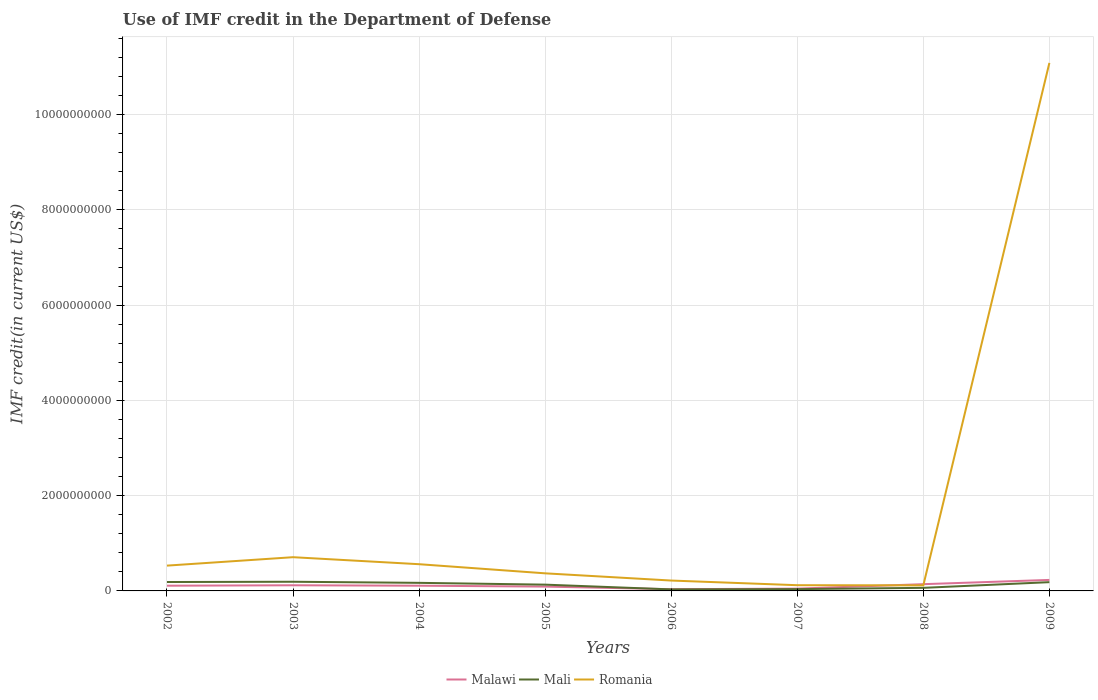Is the number of lines equal to the number of legend labels?
Keep it short and to the point. Yes. Across all years, what is the maximum IMF credit in the Department of Defense in Malawi?
Keep it short and to the point. 3.60e+07. In which year was the IMF credit in the Department of Defense in Malawi maximum?
Ensure brevity in your answer.  2006. What is the total IMF credit in the Department of Defense in Romania in the graph?
Provide a succinct answer. 4.44e+08. What is the difference between the highest and the second highest IMF credit in the Department of Defense in Malawi?
Your answer should be compact. 1.95e+08. What is the difference between two consecutive major ticks on the Y-axis?
Ensure brevity in your answer.  2.00e+09. Are the values on the major ticks of Y-axis written in scientific E-notation?
Your response must be concise. No. Does the graph contain any zero values?
Your response must be concise. No. Does the graph contain grids?
Ensure brevity in your answer.  Yes. What is the title of the graph?
Offer a terse response. Use of IMF credit in the Department of Defense. What is the label or title of the Y-axis?
Ensure brevity in your answer.  IMF credit(in current US$). What is the IMF credit(in current US$) of Malawi in 2002?
Give a very brief answer. 1.09e+08. What is the IMF credit(in current US$) of Mali in 2002?
Make the answer very short. 1.87e+08. What is the IMF credit(in current US$) of Romania in 2002?
Offer a terse response. 5.31e+08. What is the IMF credit(in current US$) in Malawi in 2003?
Your response must be concise. 1.18e+08. What is the IMF credit(in current US$) in Mali in 2003?
Give a very brief answer. 1.92e+08. What is the IMF credit(in current US$) of Romania in 2003?
Your answer should be compact. 7.08e+08. What is the IMF credit(in current US$) in Malawi in 2004?
Your response must be concise. 1.10e+08. What is the IMF credit(in current US$) in Mali in 2004?
Offer a very short reply. 1.70e+08. What is the IMF credit(in current US$) of Romania in 2004?
Offer a terse response. 5.61e+08. What is the IMF credit(in current US$) of Malawi in 2005?
Ensure brevity in your answer.  9.09e+07. What is the IMF credit(in current US$) of Mali in 2005?
Keep it short and to the point. 1.32e+08. What is the IMF credit(in current US$) of Romania in 2005?
Give a very brief answer. 3.69e+08. What is the IMF credit(in current US$) in Malawi in 2006?
Offer a very short reply. 3.60e+07. What is the IMF credit(in current US$) of Mali in 2006?
Your answer should be very brief. 3.20e+07. What is the IMF credit(in current US$) in Romania in 2006?
Offer a terse response. 2.18e+08. What is the IMF credit(in current US$) in Malawi in 2007?
Provide a succinct answer. 4.83e+07. What is the IMF credit(in current US$) in Mali in 2007?
Offer a very short reply. 3.78e+07. What is the IMF credit(in current US$) of Romania in 2007?
Your answer should be very brief. 1.20e+08. What is the IMF credit(in current US$) in Malawi in 2008?
Give a very brief answer. 1.42e+08. What is the IMF credit(in current US$) in Mali in 2008?
Give a very brief answer. 6.45e+07. What is the IMF credit(in current US$) in Romania in 2008?
Ensure brevity in your answer.  1.17e+08. What is the IMF credit(in current US$) in Malawi in 2009?
Provide a short and direct response. 2.31e+08. What is the IMF credit(in current US$) in Mali in 2009?
Make the answer very short. 1.84e+08. What is the IMF credit(in current US$) of Romania in 2009?
Your answer should be compact. 1.11e+1. Across all years, what is the maximum IMF credit(in current US$) of Malawi?
Provide a succinct answer. 2.31e+08. Across all years, what is the maximum IMF credit(in current US$) of Mali?
Keep it short and to the point. 1.92e+08. Across all years, what is the maximum IMF credit(in current US$) of Romania?
Provide a short and direct response. 1.11e+1. Across all years, what is the minimum IMF credit(in current US$) of Malawi?
Offer a terse response. 3.60e+07. Across all years, what is the minimum IMF credit(in current US$) in Mali?
Give a very brief answer. 3.20e+07. Across all years, what is the minimum IMF credit(in current US$) in Romania?
Keep it short and to the point. 1.17e+08. What is the total IMF credit(in current US$) of Malawi in the graph?
Provide a succinct answer. 8.85e+08. What is the total IMF credit(in current US$) of Mali in the graph?
Offer a very short reply. 9.99e+08. What is the total IMF credit(in current US$) of Romania in the graph?
Your answer should be compact. 1.37e+1. What is the difference between the IMF credit(in current US$) of Malawi in 2002 and that in 2003?
Make the answer very short. -9.02e+06. What is the difference between the IMF credit(in current US$) in Mali in 2002 and that in 2003?
Ensure brevity in your answer.  -5.27e+06. What is the difference between the IMF credit(in current US$) of Romania in 2002 and that in 2003?
Provide a short and direct response. -1.77e+08. What is the difference between the IMF credit(in current US$) in Malawi in 2002 and that in 2004?
Ensure brevity in your answer.  -4.00e+04. What is the difference between the IMF credit(in current US$) of Mali in 2002 and that in 2004?
Provide a short and direct response. 1.76e+07. What is the difference between the IMF credit(in current US$) in Romania in 2002 and that in 2004?
Give a very brief answer. -2.97e+07. What is the difference between the IMF credit(in current US$) in Malawi in 2002 and that in 2005?
Provide a short and direct response. 1.86e+07. What is the difference between the IMF credit(in current US$) in Mali in 2002 and that in 2005?
Your answer should be compact. 5.52e+07. What is the difference between the IMF credit(in current US$) of Romania in 2002 and that in 2005?
Provide a succinct answer. 1.62e+08. What is the difference between the IMF credit(in current US$) of Malawi in 2002 and that in 2006?
Offer a terse response. 7.35e+07. What is the difference between the IMF credit(in current US$) of Mali in 2002 and that in 2006?
Provide a succinct answer. 1.55e+08. What is the difference between the IMF credit(in current US$) of Romania in 2002 and that in 2006?
Make the answer very short. 3.14e+08. What is the difference between the IMF credit(in current US$) of Malawi in 2002 and that in 2007?
Offer a very short reply. 6.11e+07. What is the difference between the IMF credit(in current US$) in Mali in 2002 and that in 2007?
Offer a very short reply. 1.49e+08. What is the difference between the IMF credit(in current US$) in Romania in 2002 and that in 2007?
Ensure brevity in your answer.  4.11e+08. What is the difference between the IMF credit(in current US$) in Malawi in 2002 and that in 2008?
Offer a very short reply. -3.21e+07. What is the difference between the IMF credit(in current US$) of Mali in 2002 and that in 2008?
Give a very brief answer. 1.23e+08. What is the difference between the IMF credit(in current US$) of Romania in 2002 and that in 2008?
Offer a terse response. 4.14e+08. What is the difference between the IMF credit(in current US$) in Malawi in 2002 and that in 2009?
Your answer should be compact. -1.21e+08. What is the difference between the IMF credit(in current US$) in Mali in 2002 and that in 2009?
Keep it short and to the point. 3.18e+06. What is the difference between the IMF credit(in current US$) in Romania in 2002 and that in 2009?
Offer a terse response. -1.06e+1. What is the difference between the IMF credit(in current US$) of Malawi in 2003 and that in 2004?
Offer a terse response. 8.98e+06. What is the difference between the IMF credit(in current US$) of Mali in 2003 and that in 2004?
Keep it short and to the point. 2.29e+07. What is the difference between the IMF credit(in current US$) in Romania in 2003 and that in 2004?
Offer a very short reply. 1.47e+08. What is the difference between the IMF credit(in current US$) in Malawi in 2003 and that in 2005?
Make the answer very short. 2.76e+07. What is the difference between the IMF credit(in current US$) in Mali in 2003 and that in 2005?
Provide a short and direct response. 6.05e+07. What is the difference between the IMF credit(in current US$) of Romania in 2003 and that in 2005?
Give a very brief answer. 3.39e+08. What is the difference between the IMF credit(in current US$) in Malawi in 2003 and that in 2006?
Your answer should be very brief. 8.25e+07. What is the difference between the IMF credit(in current US$) in Mali in 2003 and that in 2006?
Offer a very short reply. 1.60e+08. What is the difference between the IMF credit(in current US$) of Romania in 2003 and that in 2006?
Offer a terse response. 4.90e+08. What is the difference between the IMF credit(in current US$) in Malawi in 2003 and that in 2007?
Your answer should be compact. 7.02e+07. What is the difference between the IMF credit(in current US$) of Mali in 2003 and that in 2007?
Your answer should be very brief. 1.55e+08. What is the difference between the IMF credit(in current US$) of Romania in 2003 and that in 2007?
Give a very brief answer. 5.88e+08. What is the difference between the IMF credit(in current US$) of Malawi in 2003 and that in 2008?
Your response must be concise. -2.31e+07. What is the difference between the IMF credit(in current US$) in Mali in 2003 and that in 2008?
Your answer should be very brief. 1.28e+08. What is the difference between the IMF credit(in current US$) of Romania in 2003 and that in 2008?
Your answer should be very brief. 5.91e+08. What is the difference between the IMF credit(in current US$) in Malawi in 2003 and that in 2009?
Provide a succinct answer. -1.12e+08. What is the difference between the IMF credit(in current US$) in Mali in 2003 and that in 2009?
Your answer should be compact. 8.46e+06. What is the difference between the IMF credit(in current US$) of Romania in 2003 and that in 2009?
Make the answer very short. -1.04e+1. What is the difference between the IMF credit(in current US$) of Malawi in 2004 and that in 2005?
Provide a succinct answer. 1.86e+07. What is the difference between the IMF credit(in current US$) in Mali in 2004 and that in 2005?
Your answer should be very brief. 3.76e+07. What is the difference between the IMF credit(in current US$) of Romania in 2004 and that in 2005?
Your answer should be very brief. 1.92e+08. What is the difference between the IMF credit(in current US$) of Malawi in 2004 and that in 2006?
Provide a short and direct response. 7.35e+07. What is the difference between the IMF credit(in current US$) in Mali in 2004 and that in 2006?
Provide a short and direct response. 1.38e+08. What is the difference between the IMF credit(in current US$) in Romania in 2004 and that in 2006?
Make the answer very short. 3.43e+08. What is the difference between the IMF credit(in current US$) in Malawi in 2004 and that in 2007?
Your response must be concise. 6.12e+07. What is the difference between the IMF credit(in current US$) in Mali in 2004 and that in 2007?
Make the answer very short. 1.32e+08. What is the difference between the IMF credit(in current US$) of Romania in 2004 and that in 2007?
Make the answer very short. 4.41e+08. What is the difference between the IMF credit(in current US$) in Malawi in 2004 and that in 2008?
Provide a succinct answer. -3.21e+07. What is the difference between the IMF credit(in current US$) in Mali in 2004 and that in 2008?
Keep it short and to the point. 1.05e+08. What is the difference between the IMF credit(in current US$) in Romania in 2004 and that in 2008?
Provide a succinct answer. 4.44e+08. What is the difference between the IMF credit(in current US$) in Malawi in 2004 and that in 2009?
Provide a succinct answer. -1.21e+08. What is the difference between the IMF credit(in current US$) in Mali in 2004 and that in 2009?
Provide a short and direct response. -1.45e+07. What is the difference between the IMF credit(in current US$) of Romania in 2004 and that in 2009?
Make the answer very short. -1.05e+1. What is the difference between the IMF credit(in current US$) of Malawi in 2005 and that in 2006?
Offer a terse response. 5.49e+07. What is the difference between the IMF credit(in current US$) in Mali in 2005 and that in 2006?
Offer a very short reply. 1.00e+08. What is the difference between the IMF credit(in current US$) of Romania in 2005 and that in 2006?
Your answer should be compact. 1.52e+08. What is the difference between the IMF credit(in current US$) in Malawi in 2005 and that in 2007?
Your response must be concise. 4.25e+07. What is the difference between the IMF credit(in current US$) of Mali in 2005 and that in 2007?
Offer a very short reply. 9.41e+07. What is the difference between the IMF credit(in current US$) in Romania in 2005 and that in 2007?
Make the answer very short. 2.49e+08. What is the difference between the IMF credit(in current US$) in Malawi in 2005 and that in 2008?
Ensure brevity in your answer.  -5.07e+07. What is the difference between the IMF credit(in current US$) of Mali in 2005 and that in 2008?
Your response must be concise. 6.74e+07. What is the difference between the IMF credit(in current US$) of Romania in 2005 and that in 2008?
Offer a terse response. 2.52e+08. What is the difference between the IMF credit(in current US$) of Malawi in 2005 and that in 2009?
Offer a terse response. -1.40e+08. What is the difference between the IMF credit(in current US$) of Mali in 2005 and that in 2009?
Provide a succinct answer. -5.20e+07. What is the difference between the IMF credit(in current US$) of Romania in 2005 and that in 2009?
Ensure brevity in your answer.  -1.07e+1. What is the difference between the IMF credit(in current US$) of Malawi in 2006 and that in 2007?
Offer a terse response. -1.24e+07. What is the difference between the IMF credit(in current US$) of Mali in 2006 and that in 2007?
Keep it short and to the point. -5.84e+06. What is the difference between the IMF credit(in current US$) of Romania in 2006 and that in 2007?
Keep it short and to the point. 9.79e+07. What is the difference between the IMF credit(in current US$) in Malawi in 2006 and that in 2008?
Offer a terse response. -1.06e+08. What is the difference between the IMF credit(in current US$) of Mali in 2006 and that in 2008?
Ensure brevity in your answer.  -3.26e+07. What is the difference between the IMF credit(in current US$) of Romania in 2006 and that in 2008?
Your answer should be compact. 1.01e+08. What is the difference between the IMF credit(in current US$) in Malawi in 2006 and that in 2009?
Offer a very short reply. -1.95e+08. What is the difference between the IMF credit(in current US$) in Mali in 2006 and that in 2009?
Keep it short and to the point. -1.52e+08. What is the difference between the IMF credit(in current US$) of Romania in 2006 and that in 2009?
Offer a terse response. -1.09e+1. What is the difference between the IMF credit(in current US$) in Malawi in 2007 and that in 2008?
Make the answer very short. -9.32e+07. What is the difference between the IMF credit(in current US$) in Mali in 2007 and that in 2008?
Give a very brief answer. -2.68e+07. What is the difference between the IMF credit(in current US$) of Romania in 2007 and that in 2008?
Offer a very short reply. 3.04e+06. What is the difference between the IMF credit(in current US$) in Malawi in 2007 and that in 2009?
Keep it short and to the point. -1.83e+08. What is the difference between the IMF credit(in current US$) in Mali in 2007 and that in 2009?
Your answer should be very brief. -1.46e+08. What is the difference between the IMF credit(in current US$) in Romania in 2007 and that in 2009?
Keep it short and to the point. -1.10e+1. What is the difference between the IMF credit(in current US$) in Malawi in 2008 and that in 2009?
Your answer should be very brief. -8.94e+07. What is the difference between the IMF credit(in current US$) of Mali in 2008 and that in 2009?
Offer a very short reply. -1.19e+08. What is the difference between the IMF credit(in current US$) in Romania in 2008 and that in 2009?
Ensure brevity in your answer.  -1.10e+1. What is the difference between the IMF credit(in current US$) in Malawi in 2002 and the IMF credit(in current US$) in Mali in 2003?
Offer a very short reply. -8.29e+07. What is the difference between the IMF credit(in current US$) of Malawi in 2002 and the IMF credit(in current US$) of Romania in 2003?
Offer a very short reply. -5.99e+08. What is the difference between the IMF credit(in current US$) of Mali in 2002 and the IMF credit(in current US$) of Romania in 2003?
Your answer should be very brief. -5.21e+08. What is the difference between the IMF credit(in current US$) in Malawi in 2002 and the IMF credit(in current US$) in Mali in 2004?
Give a very brief answer. -6.00e+07. What is the difference between the IMF credit(in current US$) of Malawi in 2002 and the IMF credit(in current US$) of Romania in 2004?
Your answer should be compact. -4.52e+08. What is the difference between the IMF credit(in current US$) of Mali in 2002 and the IMF credit(in current US$) of Romania in 2004?
Make the answer very short. -3.74e+08. What is the difference between the IMF credit(in current US$) of Malawi in 2002 and the IMF credit(in current US$) of Mali in 2005?
Your response must be concise. -2.25e+07. What is the difference between the IMF credit(in current US$) in Malawi in 2002 and the IMF credit(in current US$) in Romania in 2005?
Ensure brevity in your answer.  -2.60e+08. What is the difference between the IMF credit(in current US$) in Mali in 2002 and the IMF credit(in current US$) in Romania in 2005?
Provide a short and direct response. -1.82e+08. What is the difference between the IMF credit(in current US$) of Malawi in 2002 and the IMF credit(in current US$) of Mali in 2006?
Your answer should be very brief. 7.75e+07. What is the difference between the IMF credit(in current US$) of Malawi in 2002 and the IMF credit(in current US$) of Romania in 2006?
Your answer should be compact. -1.08e+08. What is the difference between the IMF credit(in current US$) of Mali in 2002 and the IMF credit(in current US$) of Romania in 2006?
Offer a terse response. -3.07e+07. What is the difference between the IMF credit(in current US$) in Malawi in 2002 and the IMF credit(in current US$) in Mali in 2007?
Your answer should be very brief. 7.17e+07. What is the difference between the IMF credit(in current US$) in Malawi in 2002 and the IMF credit(in current US$) in Romania in 2007?
Give a very brief answer. -1.05e+07. What is the difference between the IMF credit(in current US$) in Mali in 2002 and the IMF credit(in current US$) in Romania in 2007?
Your response must be concise. 6.71e+07. What is the difference between the IMF credit(in current US$) in Malawi in 2002 and the IMF credit(in current US$) in Mali in 2008?
Provide a short and direct response. 4.49e+07. What is the difference between the IMF credit(in current US$) of Malawi in 2002 and the IMF credit(in current US$) of Romania in 2008?
Offer a very short reply. -7.51e+06. What is the difference between the IMF credit(in current US$) of Mali in 2002 and the IMF credit(in current US$) of Romania in 2008?
Give a very brief answer. 7.02e+07. What is the difference between the IMF credit(in current US$) in Malawi in 2002 and the IMF credit(in current US$) in Mali in 2009?
Provide a succinct answer. -7.45e+07. What is the difference between the IMF credit(in current US$) of Malawi in 2002 and the IMF credit(in current US$) of Romania in 2009?
Offer a terse response. -1.10e+1. What is the difference between the IMF credit(in current US$) of Mali in 2002 and the IMF credit(in current US$) of Romania in 2009?
Your answer should be compact. -1.09e+1. What is the difference between the IMF credit(in current US$) in Malawi in 2003 and the IMF credit(in current US$) in Mali in 2004?
Give a very brief answer. -5.10e+07. What is the difference between the IMF credit(in current US$) of Malawi in 2003 and the IMF credit(in current US$) of Romania in 2004?
Ensure brevity in your answer.  -4.43e+08. What is the difference between the IMF credit(in current US$) in Mali in 2003 and the IMF credit(in current US$) in Romania in 2004?
Your answer should be very brief. -3.69e+08. What is the difference between the IMF credit(in current US$) in Malawi in 2003 and the IMF credit(in current US$) in Mali in 2005?
Give a very brief answer. -1.34e+07. What is the difference between the IMF credit(in current US$) of Malawi in 2003 and the IMF credit(in current US$) of Romania in 2005?
Make the answer very short. -2.51e+08. What is the difference between the IMF credit(in current US$) of Mali in 2003 and the IMF credit(in current US$) of Romania in 2005?
Your response must be concise. -1.77e+08. What is the difference between the IMF credit(in current US$) in Malawi in 2003 and the IMF credit(in current US$) in Mali in 2006?
Provide a succinct answer. 8.65e+07. What is the difference between the IMF credit(in current US$) in Malawi in 2003 and the IMF credit(in current US$) in Romania in 2006?
Your response must be concise. -9.94e+07. What is the difference between the IMF credit(in current US$) in Mali in 2003 and the IMF credit(in current US$) in Romania in 2006?
Your response must be concise. -2.55e+07. What is the difference between the IMF credit(in current US$) of Malawi in 2003 and the IMF credit(in current US$) of Mali in 2007?
Offer a terse response. 8.07e+07. What is the difference between the IMF credit(in current US$) of Malawi in 2003 and the IMF credit(in current US$) of Romania in 2007?
Offer a terse response. -1.52e+06. What is the difference between the IMF credit(in current US$) of Mali in 2003 and the IMF credit(in current US$) of Romania in 2007?
Offer a terse response. 7.24e+07. What is the difference between the IMF credit(in current US$) in Malawi in 2003 and the IMF credit(in current US$) in Mali in 2008?
Ensure brevity in your answer.  5.40e+07. What is the difference between the IMF credit(in current US$) of Malawi in 2003 and the IMF credit(in current US$) of Romania in 2008?
Ensure brevity in your answer.  1.51e+06. What is the difference between the IMF credit(in current US$) in Mali in 2003 and the IMF credit(in current US$) in Romania in 2008?
Your answer should be compact. 7.54e+07. What is the difference between the IMF credit(in current US$) of Malawi in 2003 and the IMF credit(in current US$) of Mali in 2009?
Make the answer very short. -6.55e+07. What is the difference between the IMF credit(in current US$) in Malawi in 2003 and the IMF credit(in current US$) in Romania in 2009?
Provide a succinct answer. -1.10e+1. What is the difference between the IMF credit(in current US$) of Mali in 2003 and the IMF credit(in current US$) of Romania in 2009?
Provide a succinct answer. -1.09e+1. What is the difference between the IMF credit(in current US$) of Malawi in 2004 and the IMF credit(in current US$) of Mali in 2005?
Provide a short and direct response. -2.24e+07. What is the difference between the IMF credit(in current US$) in Malawi in 2004 and the IMF credit(in current US$) in Romania in 2005?
Provide a succinct answer. -2.60e+08. What is the difference between the IMF credit(in current US$) in Mali in 2004 and the IMF credit(in current US$) in Romania in 2005?
Your response must be concise. -2.00e+08. What is the difference between the IMF credit(in current US$) in Malawi in 2004 and the IMF credit(in current US$) in Mali in 2006?
Offer a very short reply. 7.76e+07. What is the difference between the IMF credit(in current US$) in Malawi in 2004 and the IMF credit(in current US$) in Romania in 2006?
Provide a short and direct response. -1.08e+08. What is the difference between the IMF credit(in current US$) of Mali in 2004 and the IMF credit(in current US$) of Romania in 2006?
Offer a terse response. -4.84e+07. What is the difference between the IMF credit(in current US$) of Malawi in 2004 and the IMF credit(in current US$) of Mali in 2007?
Offer a terse response. 7.17e+07. What is the difference between the IMF credit(in current US$) in Malawi in 2004 and the IMF credit(in current US$) in Romania in 2007?
Offer a terse response. -1.05e+07. What is the difference between the IMF credit(in current US$) of Mali in 2004 and the IMF credit(in current US$) of Romania in 2007?
Your answer should be compact. 4.95e+07. What is the difference between the IMF credit(in current US$) in Malawi in 2004 and the IMF credit(in current US$) in Mali in 2008?
Keep it short and to the point. 4.50e+07. What is the difference between the IMF credit(in current US$) in Malawi in 2004 and the IMF credit(in current US$) in Romania in 2008?
Provide a short and direct response. -7.47e+06. What is the difference between the IMF credit(in current US$) in Mali in 2004 and the IMF credit(in current US$) in Romania in 2008?
Your answer should be very brief. 5.25e+07. What is the difference between the IMF credit(in current US$) of Malawi in 2004 and the IMF credit(in current US$) of Mali in 2009?
Make the answer very short. -7.45e+07. What is the difference between the IMF credit(in current US$) in Malawi in 2004 and the IMF credit(in current US$) in Romania in 2009?
Offer a terse response. -1.10e+1. What is the difference between the IMF credit(in current US$) in Mali in 2004 and the IMF credit(in current US$) in Romania in 2009?
Your answer should be very brief. -1.09e+1. What is the difference between the IMF credit(in current US$) of Malawi in 2005 and the IMF credit(in current US$) of Mali in 2006?
Provide a short and direct response. 5.89e+07. What is the difference between the IMF credit(in current US$) of Malawi in 2005 and the IMF credit(in current US$) of Romania in 2006?
Your answer should be compact. -1.27e+08. What is the difference between the IMF credit(in current US$) of Mali in 2005 and the IMF credit(in current US$) of Romania in 2006?
Offer a terse response. -8.60e+07. What is the difference between the IMF credit(in current US$) of Malawi in 2005 and the IMF credit(in current US$) of Mali in 2007?
Provide a short and direct response. 5.31e+07. What is the difference between the IMF credit(in current US$) in Malawi in 2005 and the IMF credit(in current US$) in Romania in 2007?
Ensure brevity in your answer.  -2.92e+07. What is the difference between the IMF credit(in current US$) of Mali in 2005 and the IMF credit(in current US$) of Romania in 2007?
Provide a succinct answer. 1.19e+07. What is the difference between the IMF credit(in current US$) of Malawi in 2005 and the IMF credit(in current US$) of Mali in 2008?
Ensure brevity in your answer.  2.63e+07. What is the difference between the IMF credit(in current US$) in Malawi in 2005 and the IMF credit(in current US$) in Romania in 2008?
Offer a terse response. -2.61e+07. What is the difference between the IMF credit(in current US$) of Mali in 2005 and the IMF credit(in current US$) of Romania in 2008?
Ensure brevity in your answer.  1.49e+07. What is the difference between the IMF credit(in current US$) in Malawi in 2005 and the IMF credit(in current US$) in Mali in 2009?
Make the answer very short. -9.31e+07. What is the difference between the IMF credit(in current US$) in Malawi in 2005 and the IMF credit(in current US$) in Romania in 2009?
Provide a short and direct response. -1.10e+1. What is the difference between the IMF credit(in current US$) in Mali in 2005 and the IMF credit(in current US$) in Romania in 2009?
Ensure brevity in your answer.  -1.10e+1. What is the difference between the IMF credit(in current US$) of Malawi in 2006 and the IMF credit(in current US$) of Mali in 2007?
Provide a succinct answer. -1.82e+06. What is the difference between the IMF credit(in current US$) of Malawi in 2006 and the IMF credit(in current US$) of Romania in 2007?
Keep it short and to the point. -8.40e+07. What is the difference between the IMF credit(in current US$) of Mali in 2006 and the IMF credit(in current US$) of Romania in 2007?
Make the answer very short. -8.81e+07. What is the difference between the IMF credit(in current US$) of Malawi in 2006 and the IMF credit(in current US$) of Mali in 2008?
Provide a short and direct response. -2.86e+07. What is the difference between the IMF credit(in current US$) of Malawi in 2006 and the IMF credit(in current US$) of Romania in 2008?
Provide a short and direct response. -8.10e+07. What is the difference between the IMF credit(in current US$) of Mali in 2006 and the IMF credit(in current US$) of Romania in 2008?
Ensure brevity in your answer.  -8.50e+07. What is the difference between the IMF credit(in current US$) in Malawi in 2006 and the IMF credit(in current US$) in Mali in 2009?
Provide a short and direct response. -1.48e+08. What is the difference between the IMF credit(in current US$) of Malawi in 2006 and the IMF credit(in current US$) of Romania in 2009?
Keep it short and to the point. -1.11e+1. What is the difference between the IMF credit(in current US$) of Mali in 2006 and the IMF credit(in current US$) of Romania in 2009?
Provide a succinct answer. -1.11e+1. What is the difference between the IMF credit(in current US$) of Malawi in 2007 and the IMF credit(in current US$) of Mali in 2008?
Provide a succinct answer. -1.62e+07. What is the difference between the IMF credit(in current US$) in Malawi in 2007 and the IMF credit(in current US$) in Romania in 2008?
Your answer should be compact. -6.86e+07. What is the difference between the IMF credit(in current US$) of Mali in 2007 and the IMF credit(in current US$) of Romania in 2008?
Offer a very short reply. -7.92e+07. What is the difference between the IMF credit(in current US$) in Malawi in 2007 and the IMF credit(in current US$) in Mali in 2009?
Keep it short and to the point. -1.36e+08. What is the difference between the IMF credit(in current US$) of Malawi in 2007 and the IMF credit(in current US$) of Romania in 2009?
Offer a very short reply. -1.10e+1. What is the difference between the IMF credit(in current US$) in Mali in 2007 and the IMF credit(in current US$) in Romania in 2009?
Keep it short and to the point. -1.11e+1. What is the difference between the IMF credit(in current US$) in Malawi in 2008 and the IMF credit(in current US$) in Mali in 2009?
Offer a terse response. -4.24e+07. What is the difference between the IMF credit(in current US$) of Malawi in 2008 and the IMF credit(in current US$) of Romania in 2009?
Provide a short and direct response. -1.09e+1. What is the difference between the IMF credit(in current US$) of Mali in 2008 and the IMF credit(in current US$) of Romania in 2009?
Your answer should be very brief. -1.10e+1. What is the average IMF credit(in current US$) in Malawi per year?
Your answer should be very brief. 1.11e+08. What is the average IMF credit(in current US$) in Mali per year?
Provide a short and direct response. 1.25e+08. What is the average IMF credit(in current US$) of Romania per year?
Make the answer very short. 1.71e+09. In the year 2002, what is the difference between the IMF credit(in current US$) in Malawi and IMF credit(in current US$) in Mali?
Give a very brief answer. -7.77e+07. In the year 2002, what is the difference between the IMF credit(in current US$) of Malawi and IMF credit(in current US$) of Romania?
Ensure brevity in your answer.  -4.22e+08. In the year 2002, what is the difference between the IMF credit(in current US$) of Mali and IMF credit(in current US$) of Romania?
Offer a very short reply. -3.44e+08. In the year 2003, what is the difference between the IMF credit(in current US$) in Malawi and IMF credit(in current US$) in Mali?
Your response must be concise. -7.39e+07. In the year 2003, what is the difference between the IMF credit(in current US$) in Malawi and IMF credit(in current US$) in Romania?
Offer a very short reply. -5.90e+08. In the year 2003, what is the difference between the IMF credit(in current US$) of Mali and IMF credit(in current US$) of Romania?
Keep it short and to the point. -5.16e+08. In the year 2004, what is the difference between the IMF credit(in current US$) of Malawi and IMF credit(in current US$) of Mali?
Make the answer very short. -6.00e+07. In the year 2004, what is the difference between the IMF credit(in current US$) in Malawi and IMF credit(in current US$) in Romania?
Ensure brevity in your answer.  -4.52e+08. In the year 2004, what is the difference between the IMF credit(in current US$) in Mali and IMF credit(in current US$) in Romania?
Your answer should be compact. -3.92e+08. In the year 2005, what is the difference between the IMF credit(in current US$) of Malawi and IMF credit(in current US$) of Mali?
Give a very brief answer. -4.11e+07. In the year 2005, what is the difference between the IMF credit(in current US$) of Malawi and IMF credit(in current US$) of Romania?
Give a very brief answer. -2.79e+08. In the year 2005, what is the difference between the IMF credit(in current US$) of Mali and IMF credit(in current US$) of Romania?
Make the answer very short. -2.38e+08. In the year 2006, what is the difference between the IMF credit(in current US$) of Malawi and IMF credit(in current US$) of Mali?
Provide a short and direct response. 4.02e+06. In the year 2006, what is the difference between the IMF credit(in current US$) of Malawi and IMF credit(in current US$) of Romania?
Offer a very short reply. -1.82e+08. In the year 2006, what is the difference between the IMF credit(in current US$) in Mali and IMF credit(in current US$) in Romania?
Give a very brief answer. -1.86e+08. In the year 2007, what is the difference between the IMF credit(in current US$) in Malawi and IMF credit(in current US$) in Mali?
Offer a terse response. 1.06e+07. In the year 2007, what is the difference between the IMF credit(in current US$) in Malawi and IMF credit(in current US$) in Romania?
Ensure brevity in your answer.  -7.17e+07. In the year 2007, what is the difference between the IMF credit(in current US$) in Mali and IMF credit(in current US$) in Romania?
Your response must be concise. -8.22e+07. In the year 2008, what is the difference between the IMF credit(in current US$) in Malawi and IMF credit(in current US$) in Mali?
Provide a succinct answer. 7.70e+07. In the year 2008, what is the difference between the IMF credit(in current US$) in Malawi and IMF credit(in current US$) in Romania?
Make the answer very short. 2.46e+07. In the year 2008, what is the difference between the IMF credit(in current US$) of Mali and IMF credit(in current US$) of Romania?
Your answer should be compact. -5.24e+07. In the year 2009, what is the difference between the IMF credit(in current US$) of Malawi and IMF credit(in current US$) of Mali?
Provide a short and direct response. 4.70e+07. In the year 2009, what is the difference between the IMF credit(in current US$) in Malawi and IMF credit(in current US$) in Romania?
Ensure brevity in your answer.  -1.09e+1. In the year 2009, what is the difference between the IMF credit(in current US$) in Mali and IMF credit(in current US$) in Romania?
Keep it short and to the point. -1.09e+1. What is the ratio of the IMF credit(in current US$) in Malawi in 2002 to that in 2003?
Your answer should be compact. 0.92. What is the ratio of the IMF credit(in current US$) in Mali in 2002 to that in 2003?
Provide a short and direct response. 0.97. What is the ratio of the IMF credit(in current US$) in Romania in 2002 to that in 2003?
Provide a short and direct response. 0.75. What is the ratio of the IMF credit(in current US$) in Mali in 2002 to that in 2004?
Make the answer very short. 1.1. What is the ratio of the IMF credit(in current US$) in Romania in 2002 to that in 2004?
Keep it short and to the point. 0.95. What is the ratio of the IMF credit(in current US$) of Malawi in 2002 to that in 2005?
Offer a terse response. 1.2. What is the ratio of the IMF credit(in current US$) in Mali in 2002 to that in 2005?
Your response must be concise. 1.42. What is the ratio of the IMF credit(in current US$) in Romania in 2002 to that in 2005?
Keep it short and to the point. 1.44. What is the ratio of the IMF credit(in current US$) of Malawi in 2002 to that in 2006?
Provide a short and direct response. 3.04. What is the ratio of the IMF credit(in current US$) in Mali in 2002 to that in 2006?
Your answer should be very brief. 5.86. What is the ratio of the IMF credit(in current US$) of Romania in 2002 to that in 2006?
Provide a short and direct response. 2.44. What is the ratio of the IMF credit(in current US$) in Malawi in 2002 to that in 2007?
Your response must be concise. 2.26. What is the ratio of the IMF credit(in current US$) of Mali in 2002 to that in 2007?
Your answer should be compact. 4.95. What is the ratio of the IMF credit(in current US$) in Romania in 2002 to that in 2007?
Offer a terse response. 4.43. What is the ratio of the IMF credit(in current US$) of Malawi in 2002 to that in 2008?
Your response must be concise. 0.77. What is the ratio of the IMF credit(in current US$) of Mali in 2002 to that in 2008?
Keep it short and to the point. 2.9. What is the ratio of the IMF credit(in current US$) in Romania in 2002 to that in 2008?
Offer a very short reply. 4.54. What is the ratio of the IMF credit(in current US$) in Malawi in 2002 to that in 2009?
Keep it short and to the point. 0.47. What is the ratio of the IMF credit(in current US$) in Mali in 2002 to that in 2009?
Your response must be concise. 1.02. What is the ratio of the IMF credit(in current US$) in Romania in 2002 to that in 2009?
Make the answer very short. 0.05. What is the ratio of the IMF credit(in current US$) in Malawi in 2003 to that in 2004?
Ensure brevity in your answer.  1.08. What is the ratio of the IMF credit(in current US$) in Mali in 2003 to that in 2004?
Your answer should be compact. 1.14. What is the ratio of the IMF credit(in current US$) of Romania in 2003 to that in 2004?
Your answer should be compact. 1.26. What is the ratio of the IMF credit(in current US$) of Malawi in 2003 to that in 2005?
Your response must be concise. 1.3. What is the ratio of the IMF credit(in current US$) in Mali in 2003 to that in 2005?
Offer a very short reply. 1.46. What is the ratio of the IMF credit(in current US$) of Romania in 2003 to that in 2005?
Provide a short and direct response. 1.92. What is the ratio of the IMF credit(in current US$) of Malawi in 2003 to that in 2006?
Make the answer very short. 3.29. What is the ratio of the IMF credit(in current US$) of Mali in 2003 to that in 2006?
Your response must be concise. 6.02. What is the ratio of the IMF credit(in current US$) in Romania in 2003 to that in 2006?
Your response must be concise. 3.25. What is the ratio of the IMF credit(in current US$) of Malawi in 2003 to that in 2007?
Ensure brevity in your answer.  2.45. What is the ratio of the IMF credit(in current US$) of Mali in 2003 to that in 2007?
Your response must be concise. 5.09. What is the ratio of the IMF credit(in current US$) in Romania in 2003 to that in 2007?
Provide a succinct answer. 5.9. What is the ratio of the IMF credit(in current US$) in Malawi in 2003 to that in 2008?
Provide a short and direct response. 0.84. What is the ratio of the IMF credit(in current US$) of Mali in 2003 to that in 2008?
Provide a succinct answer. 2.98. What is the ratio of the IMF credit(in current US$) of Romania in 2003 to that in 2008?
Ensure brevity in your answer.  6.05. What is the ratio of the IMF credit(in current US$) in Malawi in 2003 to that in 2009?
Your answer should be compact. 0.51. What is the ratio of the IMF credit(in current US$) in Mali in 2003 to that in 2009?
Offer a terse response. 1.05. What is the ratio of the IMF credit(in current US$) of Romania in 2003 to that in 2009?
Offer a very short reply. 0.06. What is the ratio of the IMF credit(in current US$) of Malawi in 2004 to that in 2005?
Provide a succinct answer. 1.21. What is the ratio of the IMF credit(in current US$) in Mali in 2004 to that in 2005?
Keep it short and to the point. 1.28. What is the ratio of the IMF credit(in current US$) of Romania in 2004 to that in 2005?
Keep it short and to the point. 1.52. What is the ratio of the IMF credit(in current US$) in Malawi in 2004 to that in 2006?
Give a very brief answer. 3.04. What is the ratio of the IMF credit(in current US$) in Mali in 2004 to that in 2006?
Give a very brief answer. 5.31. What is the ratio of the IMF credit(in current US$) of Romania in 2004 to that in 2006?
Your answer should be compact. 2.58. What is the ratio of the IMF credit(in current US$) of Malawi in 2004 to that in 2007?
Your answer should be very brief. 2.27. What is the ratio of the IMF credit(in current US$) of Mali in 2004 to that in 2007?
Make the answer very short. 4.49. What is the ratio of the IMF credit(in current US$) in Romania in 2004 to that in 2007?
Give a very brief answer. 4.68. What is the ratio of the IMF credit(in current US$) in Malawi in 2004 to that in 2008?
Provide a succinct answer. 0.77. What is the ratio of the IMF credit(in current US$) of Mali in 2004 to that in 2008?
Give a very brief answer. 2.63. What is the ratio of the IMF credit(in current US$) in Romania in 2004 to that in 2008?
Your answer should be compact. 4.8. What is the ratio of the IMF credit(in current US$) in Malawi in 2004 to that in 2009?
Provide a short and direct response. 0.47. What is the ratio of the IMF credit(in current US$) in Mali in 2004 to that in 2009?
Give a very brief answer. 0.92. What is the ratio of the IMF credit(in current US$) of Romania in 2004 to that in 2009?
Your response must be concise. 0.05. What is the ratio of the IMF credit(in current US$) of Malawi in 2005 to that in 2006?
Keep it short and to the point. 2.53. What is the ratio of the IMF credit(in current US$) of Mali in 2005 to that in 2006?
Your response must be concise. 4.13. What is the ratio of the IMF credit(in current US$) in Romania in 2005 to that in 2006?
Your answer should be very brief. 1.7. What is the ratio of the IMF credit(in current US$) in Malawi in 2005 to that in 2007?
Ensure brevity in your answer.  1.88. What is the ratio of the IMF credit(in current US$) in Mali in 2005 to that in 2007?
Your answer should be very brief. 3.49. What is the ratio of the IMF credit(in current US$) of Romania in 2005 to that in 2007?
Offer a very short reply. 3.08. What is the ratio of the IMF credit(in current US$) in Malawi in 2005 to that in 2008?
Provide a succinct answer. 0.64. What is the ratio of the IMF credit(in current US$) in Mali in 2005 to that in 2008?
Your answer should be very brief. 2.04. What is the ratio of the IMF credit(in current US$) of Romania in 2005 to that in 2008?
Your response must be concise. 3.16. What is the ratio of the IMF credit(in current US$) in Malawi in 2005 to that in 2009?
Ensure brevity in your answer.  0.39. What is the ratio of the IMF credit(in current US$) in Mali in 2005 to that in 2009?
Your answer should be very brief. 0.72. What is the ratio of the IMF credit(in current US$) of Romania in 2005 to that in 2009?
Your response must be concise. 0.03. What is the ratio of the IMF credit(in current US$) in Malawi in 2006 to that in 2007?
Provide a succinct answer. 0.74. What is the ratio of the IMF credit(in current US$) of Mali in 2006 to that in 2007?
Provide a short and direct response. 0.85. What is the ratio of the IMF credit(in current US$) of Romania in 2006 to that in 2007?
Your answer should be very brief. 1.82. What is the ratio of the IMF credit(in current US$) in Malawi in 2006 to that in 2008?
Provide a succinct answer. 0.25. What is the ratio of the IMF credit(in current US$) in Mali in 2006 to that in 2008?
Your answer should be compact. 0.49. What is the ratio of the IMF credit(in current US$) in Romania in 2006 to that in 2008?
Provide a succinct answer. 1.86. What is the ratio of the IMF credit(in current US$) of Malawi in 2006 to that in 2009?
Your answer should be very brief. 0.16. What is the ratio of the IMF credit(in current US$) of Mali in 2006 to that in 2009?
Your answer should be compact. 0.17. What is the ratio of the IMF credit(in current US$) of Romania in 2006 to that in 2009?
Provide a short and direct response. 0.02. What is the ratio of the IMF credit(in current US$) in Malawi in 2007 to that in 2008?
Provide a short and direct response. 0.34. What is the ratio of the IMF credit(in current US$) in Mali in 2007 to that in 2008?
Offer a very short reply. 0.59. What is the ratio of the IMF credit(in current US$) of Malawi in 2007 to that in 2009?
Ensure brevity in your answer.  0.21. What is the ratio of the IMF credit(in current US$) in Mali in 2007 to that in 2009?
Offer a terse response. 0.21. What is the ratio of the IMF credit(in current US$) in Romania in 2007 to that in 2009?
Provide a short and direct response. 0.01. What is the ratio of the IMF credit(in current US$) of Malawi in 2008 to that in 2009?
Your answer should be compact. 0.61. What is the ratio of the IMF credit(in current US$) of Mali in 2008 to that in 2009?
Give a very brief answer. 0.35. What is the ratio of the IMF credit(in current US$) in Romania in 2008 to that in 2009?
Your response must be concise. 0.01. What is the difference between the highest and the second highest IMF credit(in current US$) of Malawi?
Provide a short and direct response. 8.94e+07. What is the difference between the highest and the second highest IMF credit(in current US$) in Mali?
Keep it short and to the point. 5.27e+06. What is the difference between the highest and the second highest IMF credit(in current US$) in Romania?
Your answer should be compact. 1.04e+1. What is the difference between the highest and the lowest IMF credit(in current US$) of Malawi?
Offer a very short reply. 1.95e+08. What is the difference between the highest and the lowest IMF credit(in current US$) in Mali?
Keep it short and to the point. 1.60e+08. What is the difference between the highest and the lowest IMF credit(in current US$) in Romania?
Keep it short and to the point. 1.10e+1. 